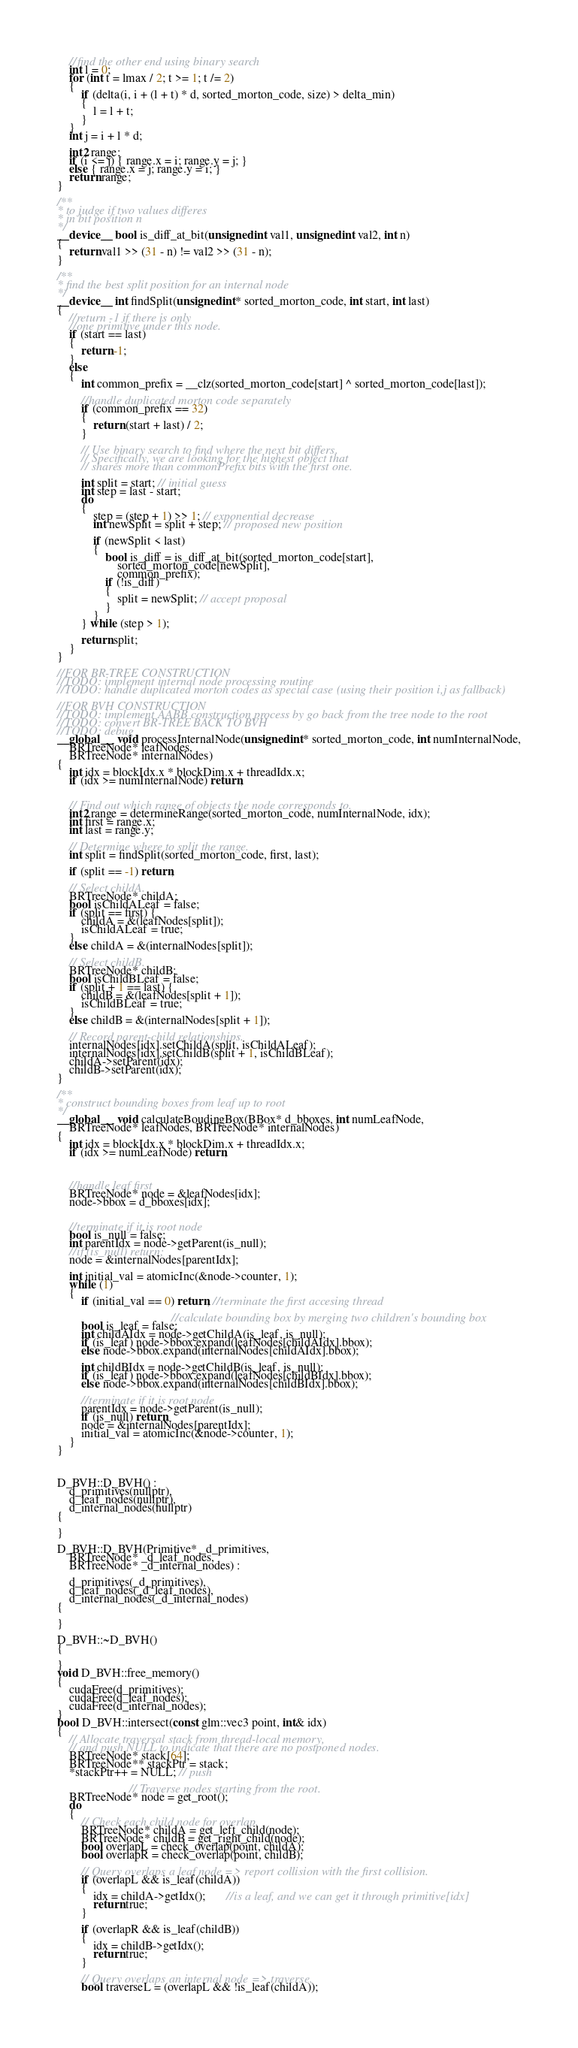Convert code to text. <code><loc_0><loc_0><loc_500><loc_500><_Cuda_>	//find the other end using binary search
	int l = 0;
	for (int t = lmax / 2; t >= 1; t /= 2)
	{
		if (delta(i, i + (l + t) * d, sorted_morton_code, size) > delta_min)
		{
			l = l + t;
		}
	}
	int j = i + l * d;

	int2 range;
	if (i <= j) { range.x = i; range.y = j; }
	else { range.x = j; range.y = i; }
	return range;
}

/**
* to judge if two values differes
* in bit position n
*/
__device__ bool is_diff_at_bit(unsigned int val1, unsigned int val2, int n)
{
	return val1 >> (31 - n) != val2 >> (31 - n);
}

/**
* find the best split position for an internal node
*/
__device__ int findSplit(unsigned int* sorted_morton_code, int start, int last)
{
	//return -1 if there is only 
	//one primitive under this node.
	if (start == last)
	{
		return -1;
	}
	else
	{
		int common_prefix = __clz(sorted_morton_code[start] ^ sorted_morton_code[last]);

		//handle duplicated morton code separately
		if (common_prefix == 32)
		{
			return (start + last) / 2;
		}

		// Use binary search to find where the next bit differs.
		// Specifically, we are looking for the highest object that
		// shares more than commonPrefix bits with the first one.

		int split = start; // initial guess
		int step = last - start;
		do
		{
			step = (step + 1) >> 1; // exponential decrease
			int newSplit = split + step; // proposed new position

			if (newSplit < last)
			{
				bool is_diff = is_diff_at_bit(sorted_morton_code[start],
					sorted_morton_code[newSplit],
					common_prefix);
				if (!is_diff)
				{
					split = newSplit; // accept proposal
				}
			}
		} while (step > 1);

		return split;
	}
}

//FOR BR-TREE CONSTRUCTION
//TODO: implement internal node processing routine
//TODO: handle duplicated morton codes as special case (using their position i,j as fallback)

//FOR BVH CONSTRUCTION
//TODO: implement AABB construction process by go back from the tree node to the root
//TODO: convert BR-TREE BACK TO BVH
//TODO: debug
__global__  void processInternalNode(unsigned int* sorted_morton_code, int numInternalNode,
	BRTreeNode* leafNodes,
	BRTreeNode* internalNodes)
{
	int idx = blockIdx.x * blockDim.x + threadIdx.x;
	if (idx >= numInternalNode) return;


	// Find out which range of objects the node corresponds to.
	int2 range = determineRange(sorted_morton_code, numInternalNode, idx);
	int first = range.x;
	int last = range.y;

	// Determine where to split the range.
	int split = findSplit(sorted_morton_code, first, last);

	if (split == -1) return;

	// Select childA.
	BRTreeNode* childA;
	bool isChildALeaf = false;
	if (split == first) {
		childA = &(leafNodes[split]);
		isChildALeaf = true;
	}
	else childA = &(internalNodes[split]);

	// Select childB.
	BRTreeNode* childB;
	bool isChildBLeaf = false;
	if (split + 1 == last) {
		childB = &(leafNodes[split + 1]);
		isChildBLeaf = true;
	}
	else childB = &(internalNodes[split + 1]);

	// Record parent-child relationships.
	internalNodes[idx].setChildA(split, isChildALeaf);
	internalNodes[idx].setChildB(split + 1, isChildBLeaf);
	childA->setParent(idx);
	childB->setParent(idx);
}

/**
* construct bounding boxes from leaf up to root
*/
__global__  void calculateBoudingBox(BBox* d_bboxes, int numLeafNode,
	BRTreeNode* leafNodes, BRTreeNode* internalNodes)
{
	int idx = blockIdx.x * blockDim.x + threadIdx.x;
	if (idx >= numLeafNode) return;



	//handle leaf first
	BRTreeNode* node = &leafNodes[idx];
	node->bbox = d_bboxes[idx];


	//terminate if it is root node
	bool is_null = false;
	int parentIdx = node->getParent(is_null);
	//if (is_null) return;
	node = &internalNodes[parentIdx];

	int initial_val = atomicInc(&node->counter, 1);
	while (1)
	{
		if (initial_val == 0) return; //terminate the first accesing thread

									  //calculate bounding box by merging two children's bounding box
		bool is_leaf = false;
		int childAIdx = node->getChildA(is_leaf, is_null);
		if (is_leaf) node->bbox.expand(leafNodes[childAIdx].bbox);
		else node->bbox.expand(internalNodes[childAIdx].bbox);

		int childBIdx = node->getChildB(is_leaf, is_null);
		if (is_leaf) node->bbox.expand(leafNodes[childBIdx].bbox);
		else node->bbox.expand(internalNodes[childBIdx].bbox);

		//terminate if it is root node
		parentIdx = node->getParent(is_null);
		if (is_null) return;
		node = &internalNodes[parentIdx];
		initial_val = atomicInc(&node->counter, 1);
	}
}



D_BVH::D_BVH() :
	d_primitives(nullptr),
	d_leaf_nodes(nullptr),
	d_internal_nodes(nullptr)
{

}

D_BVH::D_BVH(Primitive* _d_primitives,
	BRTreeNode* _d_leaf_nodes,
	BRTreeNode* _d_internal_nodes) :

	d_primitives(_d_primitives),
	d_leaf_nodes(_d_leaf_nodes),
	d_internal_nodes(_d_internal_nodes)
{

}

D_BVH::~D_BVH()
{

}
void D_BVH::free_memory()
{
	cudaFree(d_primitives);
	cudaFree(d_leaf_nodes);
	cudaFree(d_internal_nodes);
}
bool D_BVH::intersect(const glm::vec3 point, int& idx)
{
	// Allocate traversal stack from thread-local memory,
	// and push NULL to indicate that there are no postponed nodes.
	BRTreeNode* stack[64];
	BRTreeNode** stackPtr = stack;
	*stackPtr++ = NULL; // push

						// Traverse nodes starting from the root.
	BRTreeNode* node = get_root();
	do
	{
		// Check each child node for overlap.
		BRTreeNode* childA = get_left_child(node);
		BRTreeNode* childB = get_right_child(node);
		bool overlapL = check_overlap(point, childA);
		bool overlapR = check_overlap(point, childB);

		// Query overlaps a leaf node => report collision with the first collision.
		if (overlapL && is_leaf(childA))
		{
			idx = childA->getIdx();       //is a leaf, and we can get it through primitive[idx]
			return true;
		}

		if (overlapR && is_leaf(childB))
		{
			idx = childB->getIdx();
			return true;
		}

		// Query overlaps an internal node => traverse.
		bool traverseL = (overlapL && !is_leaf(childA));</code> 